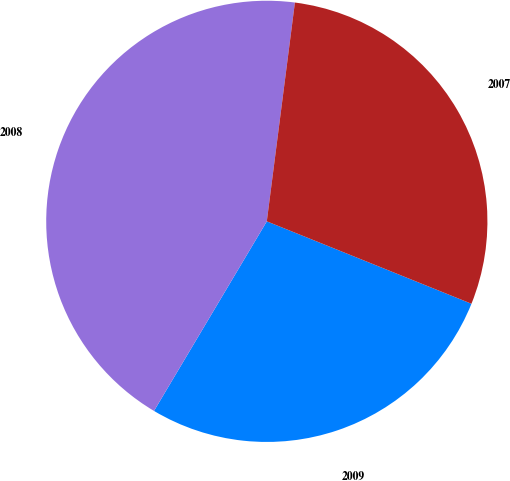Convert chart to OTSL. <chart><loc_0><loc_0><loc_500><loc_500><pie_chart><fcel>2009<fcel>2008<fcel>2007<nl><fcel>27.45%<fcel>43.49%<fcel>29.06%<nl></chart> 